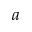<formula> <loc_0><loc_0><loc_500><loc_500>a</formula> 